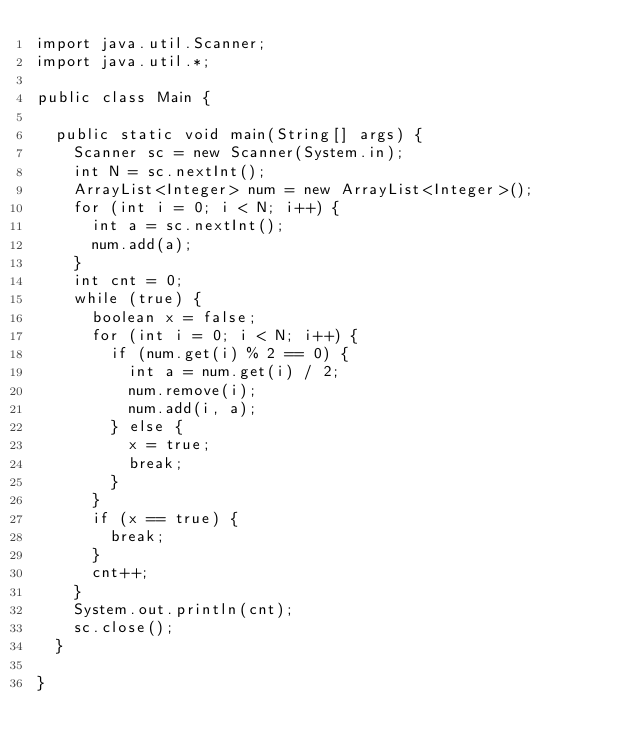<code> <loc_0><loc_0><loc_500><loc_500><_Java_>import java.util.Scanner;
import java.util.*;

public class Main {

	public static void main(String[] args) {
		Scanner sc = new Scanner(System.in);
		int N = sc.nextInt();
		ArrayList<Integer> num = new ArrayList<Integer>();
		for (int i = 0; i < N; i++) {
			int a = sc.nextInt();
			num.add(a);
		}
		int cnt = 0;
		while (true) {
			boolean x = false;
			for (int i = 0; i < N; i++) {
				if (num.get(i) % 2 == 0) {
					int a = num.get(i) / 2;
					num.remove(i);
					num.add(i, a);
				} else {
					x = true;
					break;
				}
			}
			if (x == true) {
				break;
			}
			cnt++;
		}
		System.out.println(cnt);
		sc.close();
	}

}</code> 